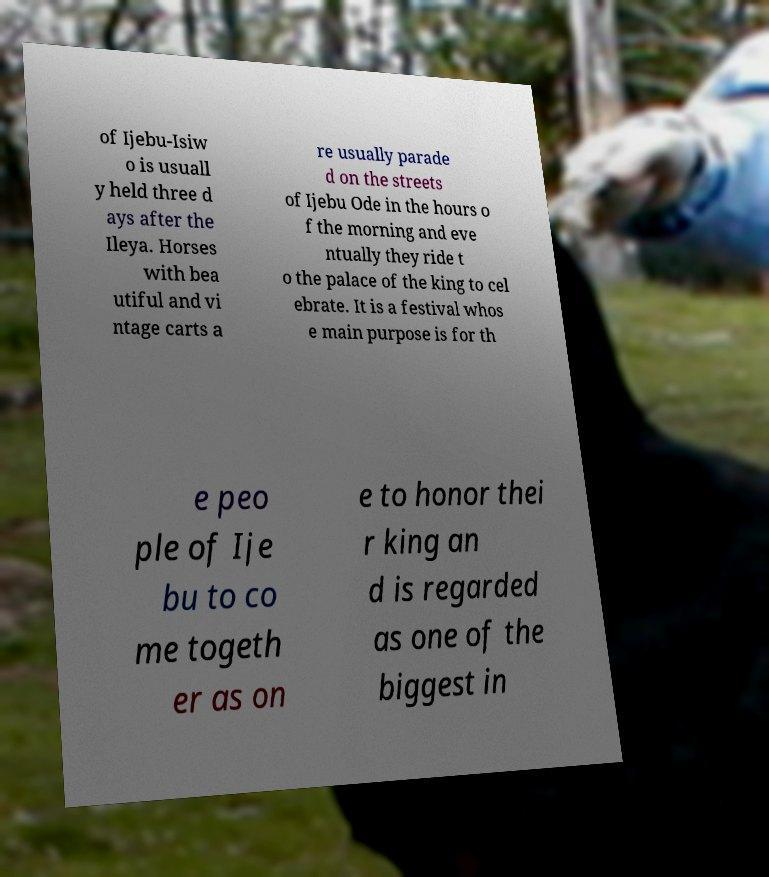Can you read and provide the text displayed in the image?This photo seems to have some interesting text. Can you extract and type it out for me? of Ijebu-Isiw o is usuall y held three d ays after the Ileya. Horses with bea utiful and vi ntage carts a re usually parade d on the streets of Ijebu Ode in the hours o f the morning and eve ntually they ride t o the palace of the king to cel ebrate. It is a festival whos e main purpose is for th e peo ple of Ije bu to co me togeth er as on e to honor thei r king an d is regarded as one of the biggest in 